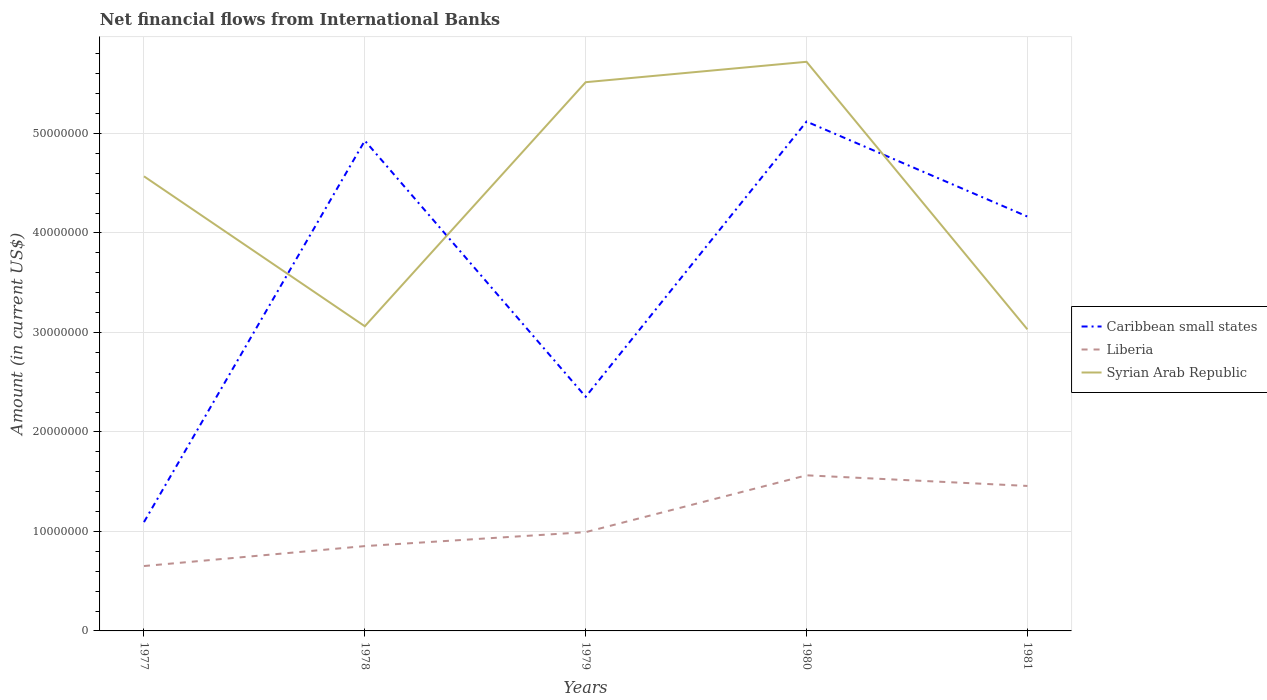How many different coloured lines are there?
Give a very brief answer. 3. Does the line corresponding to Caribbean small states intersect with the line corresponding to Syrian Arab Republic?
Your answer should be compact. Yes. Is the number of lines equal to the number of legend labels?
Your answer should be very brief. Yes. Across all years, what is the maximum net financial aid flows in Syrian Arab Republic?
Provide a succinct answer. 3.03e+07. What is the total net financial aid flows in Caribbean small states in the graph?
Your response must be concise. -1.81e+07. What is the difference between the highest and the second highest net financial aid flows in Liberia?
Provide a succinct answer. 9.12e+06. How many years are there in the graph?
Keep it short and to the point. 5. Are the values on the major ticks of Y-axis written in scientific E-notation?
Give a very brief answer. No. Does the graph contain any zero values?
Keep it short and to the point. No. Does the graph contain grids?
Your answer should be compact. Yes. What is the title of the graph?
Offer a very short reply. Net financial flows from International Banks. Does "Aruba" appear as one of the legend labels in the graph?
Make the answer very short. No. What is the label or title of the X-axis?
Your answer should be very brief. Years. What is the Amount (in current US$) in Caribbean small states in 1977?
Provide a succinct answer. 1.09e+07. What is the Amount (in current US$) of Liberia in 1977?
Give a very brief answer. 6.52e+06. What is the Amount (in current US$) in Syrian Arab Republic in 1977?
Keep it short and to the point. 4.57e+07. What is the Amount (in current US$) in Caribbean small states in 1978?
Your response must be concise. 4.93e+07. What is the Amount (in current US$) of Liberia in 1978?
Your answer should be very brief. 8.53e+06. What is the Amount (in current US$) of Syrian Arab Republic in 1978?
Your answer should be compact. 3.06e+07. What is the Amount (in current US$) of Caribbean small states in 1979?
Make the answer very short. 2.35e+07. What is the Amount (in current US$) in Liberia in 1979?
Provide a succinct answer. 9.93e+06. What is the Amount (in current US$) in Syrian Arab Republic in 1979?
Provide a short and direct response. 5.52e+07. What is the Amount (in current US$) in Caribbean small states in 1980?
Make the answer very short. 5.12e+07. What is the Amount (in current US$) of Liberia in 1980?
Provide a short and direct response. 1.56e+07. What is the Amount (in current US$) in Syrian Arab Republic in 1980?
Offer a very short reply. 5.72e+07. What is the Amount (in current US$) in Caribbean small states in 1981?
Your response must be concise. 4.16e+07. What is the Amount (in current US$) in Liberia in 1981?
Give a very brief answer. 1.46e+07. What is the Amount (in current US$) in Syrian Arab Republic in 1981?
Provide a short and direct response. 3.03e+07. Across all years, what is the maximum Amount (in current US$) in Caribbean small states?
Offer a very short reply. 5.12e+07. Across all years, what is the maximum Amount (in current US$) of Liberia?
Provide a short and direct response. 1.56e+07. Across all years, what is the maximum Amount (in current US$) in Syrian Arab Republic?
Make the answer very short. 5.72e+07. Across all years, what is the minimum Amount (in current US$) of Caribbean small states?
Your answer should be compact. 1.09e+07. Across all years, what is the minimum Amount (in current US$) of Liberia?
Offer a very short reply. 6.52e+06. Across all years, what is the minimum Amount (in current US$) in Syrian Arab Republic?
Ensure brevity in your answer.  3.03e+07. What is the total Amount (in current US$) in Caribbean small states in the graph?
Make the answer very short. 1.77e+08. What is the total Amount (in current US$) of Liberia in the graph?
Give a very brief answer. 5.52e+07. What is the total Amount (in current US$) of Syrian Arab Republic in the graph?
Provide a succinct answer. 2.19e+08. What is the difference between the Amount (in current US$) of Caribbean small states in 1977 and that in 1978?
Your answer should be compact. -3.83e+07. What is the difference between the Amount (in current US$) in Liberia in 1977 and that in 1978?
Offer a very short reply. -2.00e+06. What is the difference between the Amount (in current US$) in Syrian Arab Republic in 1977 and that in 1978?
Keep it short and to the point. 1.51e+07. What is the difference between the Amount (in current US$) in Caribbean small states in 1977 and that in 1979?
Keep it short and to the point. -1.26e+07. What is the difference between the Amount (in current US$) of Liberia in 1977 and that in 1979?
Make the answer very short. -3.41e+06. What is the difference between the Amount (in current US$) in Syrian Arab Republic in 1977 and that in 1979?
Offer a terse response. -9.46e+06. What is the difference between the Amount (in current US$) of Caribbean small states in 1977 and that in 1980?
Offer a very short reply. -4.03e+07. What is the difference between the Amount (in current US$) in Liberia in 1977 and that in 1980?
Give a very brief answer. -9.12e+06. What is the difference between the Amount (in current US$) of Syrian Arab Republic in 1977 and that in 1980?
Keep it short and to the point. -1.15e+07. What is the difference between the Amount (in current US$) in Caribbean small states in 1977 and that in 1981?
Offer a terse response. -3.07e+07. What is the difference between the Amount (in current US$) of Liberia in 1977 and that in 1981?
Make the answer very short. -8.05e+06. What is the difference between the Amount (in current US$) in Syrian Arab Republic in 1977 and that in 1981?
Offer a terse response. 1.54e+07. What is the difference between the Amount (in current US$) of Caribbean small states in 1978 and that in 1979?
Ensure brevity in your answer.  2.57e+07. What is the difference between the Amount (in current US$) of Liberia in 1978 and that in 1979?
Provide a short and direct response. -1.40e+06. What is the difference between the Amount (in current US$) of Syrian Arab Republic in 1978 and that in 1979?
Your answer should be very brief. -2.45e+07. What is the difference between the Amount (in current US$) in Caribbean small states in 1978 and that in 1980?
Keep it short and to the point. -1.92e+06. What is the difference between the Amount (in current US$) of Liberia in 1978 and that in 1980?
Your answer should be very brief. -7.11e+06. What is the difference between the Amount (in current US$) of Syrian Arab Republic in 1978 and that in 1980?
Offer a very short reply. -2.66e+07. What is the difference between the Amount (in current US$) of Caribbean small states in 1978 and that in 1981?
Give a very brief answer. 7.63e+06. What is the difference between the Amount (in current US$) of Liberia in 1978 and that in 1981?
Provide a succinct answer. -6.05e+06. What is the difference between the Amount (in current US$) in Syrian Arab Republic in 1978 and that in 1981?
Offer a very short reply. 3.11e+05. What is the difference between the Amount (in current US$) of Caribbean small states in 1979 and that in 1980?
Your answer should be very brief. -2.77e+07. What is the difference between the Amount (in current US$) of Liberia in 1979 and that in 1980?
Your answer should be very brief. -5.71e+06. What is the difference between the Amount (in current US$) of Syrian Arab Republic in 1979 and that in 1980?
Your answer should be very brief. -2.05e+06. What is the difference between the Amount (in current US$) in Caribbean small states in 1979 and that in 1981?
Your answer should be very brief. -1.81e+07. What is the difference between the Amount (in current US$) in Liberia in 1979 and that in 1981?
Offer a terse response. -4.64e+06. What is the difference between the Amount (in current US$) of Syrian Arab Republic in 1979 and that in 1981?
Ensure brevity in your answer.  2.48e+07. What is the difference between the Amount (in current US$) of Caribbean small states in 1980 and that in 1981?
Your answer should be very brief. 9.55e+06. What is the difference between the Amount (in current US$) of Liberia in 1980 and that in 1981?
Make the answer very short. 1.07e+06. What is the difference between the Amount (in current US$) in Syrian Arab Republic in 1980 and that in 1981?
Provide a succinct answer. 2.69e+07. What is the difference between the Amount (in current US$) in Caribbean small states in 1977 and the Amount (in current US$) in Liberia in 1978?
Ensure brevity in your answer.  2.41e+06. What is the difference between the Amount (in current US$) in Caribbean small states in 1977 and the Amount (in current US$) in Syrian Arab Republic in 1978?
Keep it short and to the point. -1.97e+07. What is the difference between the Amount (in current US$) in Liberia in 1977 and the Amount (in current US$) in Syrian Arab Republic in 1978?
Your answer should be very brief. -2.41e+07. What is the difference between the Amount (in current US$) of Caribbean small states in 1977 and the Amount (in current US$) of Liberia in 1979?
Provide a succinct answer. 1.01e+06. What is the difference between the Amount (in current US$) of Caribbean small states in 1977 and the Amount (in current US$) of Syrian Arab Republic in 1979?
Offer a very short reply. -4.42e+07. What is the difference between the Amount (in current US$) of Liberia in 1977 and the Amount (in current US$) of Syrian Arab Republic in 1979?
Offer a terse response. -4.86e+07. What is the difference between the Amount (in current US$) in Caribbean small states in 1977 and the Amount (in current US$) in Liberia in 1980?
Your response must be concise. -4.70e+06. What is the difference between the Amount (in current US$) in Caribbean small states in 1977 and the Amount (in current US$) in Syrian Arab Republic in 1980?
Your response must be concise. -4.63e+07. What is the difference between the Amount (in current US$) in Liberia in 1977 and the Amount (in current US$) in Syrian Arab Republic in 1980?
Offer a very short reply. -5.07e+07. What is the difference between the Amount (in current US$) in Caribbean small states in 1977 and the Amount (in current US$) in Liberia in 1981?
Give a very brief answer. -3.63e+06. What is the difference between the Amount (in current US$) in Caribbean small states in 1977 and the Amount (in current US$) in Syrian Arab Republic in 1981?
Keep it short and to the point. -1.94e+07. What is the difference between the Amount (in current US$) of Liberia in 1977 and the Amount (in current US$) of Syrian Arab Republic in 1981?
Ensure brevity in your answer.  -2.38e+07. What is the difference between the Amount (in current US$) in Caribbean small states in 1978 and the Amount (in current US$) in Liberia in 1979?
Your answer should be compact. 3.93e+07. What is the difference between the Amount (in current US$) of Caribbean small states in 1978 and the Amount (in current US$) of Syrian Arab Republic in 1979?
Give a very brief answer. -5.88e+06. What is the difference between the Amount (in current US$) in Liberia in 1978 and the Amount (in current US$) in Syrian Arab Republic in 1979?
Make the answer very short. -4.66e+07. What is the difference between the Amount (in current US$) of Caribbean small states in 1978 and the Amount (in current US$) of Liberia in 1980?
Ensure brevity in your answer.  3.36e+07. What is the difference between the Amount (in current US$) in Caribbean small states in 1978 and the Amount (in current US$) in Syrian Arab Republic in 1980?
Your answer should be very brief. -7.93e+06. What is the difference between the Amount (in current US$) in Liberia in 1978 and the Amount (in current US$) in Syrian Arab Republic in 1980?
Offer a terse response. -4.87e+07. What is the difference between the Amount (in current US$) of Caribbean small states in 1978 and the Amount (in current US$) of Liberia in 1981?
Provide a succinct answer. 3.47e+07. What is the difference between the Amount (in current US$) of Caribbean small states in 1978 and the Amount (in current US$) of Syrian Arab Republic in 1981?
Provide a short and direct response. 1.90e+07. What is the difference between the Amount (in current US$) in Liberia in 1978 and the Amount (in current US$) in Syrian Arab Republic in 1981?
Your answer should be very brief. -2.18e+07. What is the difference between the Amount (in current US$) in Caribbean small states in 1979 and the Amount (in current US$) in Liberia in 1980?
Keep it short and to the point. 7.90e+06. What is the difference between the Amount (in current US$) in Caribbean small states in 1979 and the Amount (in current US$) in Syrian Arab Republic in 1980?
Ensure brevity in your answer.  -3.37e+07. What is the difference between the Amount (in current US$) in Liberia in 1979 and the Amount (in current US$) in Syrian Arab Republic in 1980?
Your answer should be compact. -4.73e+07. What is the difference between the Amount (in current US$) of Caribbean small states in 1979 and the Amount (in current US$) of Liberia in 1981?
Provide a succinct answer. 8.96e+06. What is the difference between the Amount (in current US$) of Caribbean small states in 1979 and the Amount (in current US$) of Syrian Arab Republic in 1981?
Offer a terse response. -6.78e+06. What is the difference between the Amount (in current US$) of Liberia in 1979 and the Amount (in current US$) of Syrian Arab Republic in 1981?
Offer a very short reply. -2.04e+07. What is the difference between the Amount (in current US$) of Caribbean small states in 1980 and the Amount (in current US$) of Liberia in 1981?
Provide a short and direct response. 3.66e+07. What is the difference between the Amount (in current US$) of Caribbean small states in 1980 and the Amount (in current US$) of Syrian Arab Republic in 1981?
Give a very brief answer. 2.09e+07. What is the difference between the Amount (in current US$) in Liberia in 1980 and the Amount (in current US$) in Syrian Arab Republic in 1981?
Make the answer very short. -1.47e+07. What is the average Amount (in current US$) of Caribbean small states per year?
Provide a short and direct response. 3.53e+07. What is the average Amount (in current US$) in Liberia per year?
Your response must be concise. 1.10e+07. What is the average Amount (in current US$) in Syrian Arab Republic per year?
Offer a terse response. 4.38e+07. In the year 1977, what is the difference between the Amount (in current US$) of Caribbean small states and Amount (in current US$) of Liberia?
Keep it short and to the point. 4.42e+06. In the year 1977, what is the difference between the Amount (in current US$) in Caribbean small states and Amount (in current US$) in Syrian Arab Republic?
Your response must be concise. -3.48e+07. In the year 1977, what is the difference between the Amount (in current US$) of Liberia and Amount (in current US$) of Syrian Arab Republic?
Your response must be concise. -3.92e+07. In the year 1978, what is the difference between the Amount (in current US$) in Caribbean small states and Amount (in current US$) in Liberia?
Offer a terse response. 4.08e+07. In the year 1978, what is the difference between the Amount (in current US$) in Caribbean small states and Amount (in current US$) in Syrian Arab Republic?
Ensure brevity in your answer.  1.87e+07. In the year 1978, what is the difference between the Amount (in current US$) in Liberia and Amount (in current US$) in Syrian Arab Republic?
Offer a very short reply. -2.21e+07. In the year 1979, what is the difference between the Amount (in current US$) of Caribbean small states and Amount (in current US$) of Liberia?
Make the answer very short. 1.36e+07. In the year 1979, what is the difference between the Amount (in current US$) of Caribbean small states and Amount (in current US$) of Syrian Arab Republic?
Provide a short and direct response. -3.16e+07. In the year 1979, what is the difference between the Amount (in current US$) in Liberia and Amount (in current US$) in Syrian Arab Republic?
Make the answer very short. -4.52e+07. In the year 1980, what is the difference between the Amount (in current US$) in Caribbean small states and Amount (in current US$) in Liberia?
Ensure brevity in your answer.  3.56e+07. In the year 1980, what is the difference between the Amount (in current US$) in Caribbean small states and Amount (in current US$) in Syrian Arab Republic?
Offer a very short reply. -6.01e+06. In the year 1980, what is the difference between the Amount (in current US$) in Liberia and Amount (in current US$) in Syrian Arab Republic?
Your answer should be very brief. -4.16e+07. In the year 1981, what is the difference between the Amount (in current US$) of Caribbean small states and Amount (in current US$) of Liberia?
Ensure brevity in your answer.  2.71e+07. In the year 1981, what is the difference between the Amount (in current US$) of Caribbean small states and Amount (in current US$) of Syrian Arab Republic?
Provide a succinct answer. 1.13e+07. In the year 1981, what is the difference between the Amount (in current US$) in Liberia and Amount (in current US$) in Syrian Arab Republic?
Your answer should be compact. -1.57e+07. What is the ratio of the Amount (in current US$) in Caribbean small states in 1977 to that in 1978?
Offer a terse response. 0.22. What is the ratio of the Amount (in current US$) of Liberia in 1977 to that in 1978?
Offer a very short reply. 0.77. What is the ratio of the Amount (in current US$) in Syrian Arab Republic in 1977 to that in 1978?
Provide a short and direct response. 1.49. What is the ratio of the Amount (in current US$) of Caribbean small states in 1977 to that in 1979?
Make the answer very short. 0.46. What is the ratio of the Amount (in current US$) of Liberia in 1977 to that in 1979?
Your response must be concise. 0.66. What is the ratio of the Amount (in current US$) of Syrian Arab Republic in 1977 to that in 1979?
Make the answer very short. 0.83. What is the ratio of the Amount (in current US$) of Caribbean small states in 1977 to that in 1980?
Give a very brief answer. 0.21. What is the ratio of the Amount (in current US$) of Liberia in 1977 to that in 1980?
Provide a succinct answer. 0.42. What is the ratio of the Amount (in current US$) of Syrian Arab Republic in 1977 to that in 1980?
Provide a succinct answer. 0.8. What is the ratio of the Amount (in current US$) of Caribbean small states in 1977 to that in 1981?
Make the answer very short. 0.26. What is the ratio of the Amount (in current US$) of Liberia in 1977 to that in 1981?
Make the answer very short. 0.45. What is the ratio of the Amount (in current US$) of Syrian Arab Republic in 1977 to that in 1981?
Offer a very short reply. 1.51. What is the ratio of the Amount (in current US$) in Caribbean small states in 1978 to that in 1979?
Keep it short and to the point. 2.09. What is the ratio of the Amount (in current US$) in Liberia in 1978 to that in 1979?
Provide a succinct answer. 0.86. What is the ratio of the Amount (in current US$) of Syrian Arab Republic in 1978 to that in 1979?
Offer a very short reply. 0.56. What is the ratio of the Amount (in current US$) of Caribbean small states in 1978 to that in 1980?
Keep it short and to the point. 0.96. What is the ratio of the Amount (in current US$) in Liberia in 1978 to that in 1980?
Your answer should be compact. 0.55. What is the ratio of the Amount (in current US$) of Syrian Arab Republic in 1978 to that in 1980?
Keep it short and to the point. 0.54. What is the ratio of the Amount (in current US$) in Caribbean small states in 1978 to that in 1981?
Offer a terse response. 1.18. What is the ratio of the Amount (in current US$) of Liberia in 1978 to that in 1981?
Give a very brief answer. 0.59. What is the ratio of the Amount (in current US$) of Syrian Arab Republic in 1978 to that in 1981?
Your answer should be very brief. 1.01. What is the ratio of the Amount (in current US$) of Caribbean small states in 1979 to that in 1980?
Offer a very short reply. 0.46. What is the ratio of the Amount (in current US$) in Liberia in 1979 to that in 1980?
Provide a short and direct response. 0.63. What is the ratio of the Amount (in current US$) in Syrian Arab Republic in 1979 to that in 1980?
Keep it short and to the point. 0.96. What is the ratio of the Amount (in current US$) of Caribbean small states in 1979 to that in 1981?
Make the answer very short. 0.57. What is the ratio of the Amount (in current US$) in Liberia in 1979 to that in 1981?
Provide a succinct answer. 0.68. What is the ratio of the Amount (in current US$) in Syrian Arab Republic in 1979 to that in 1981?
Give a very brief answer. 1.82. What is the ratio of the Amount (in current US$) in Caribbean small states in 1980 to that in 1981?
Your answer should be very brief. 1.23. What is the ratio of the Amount (in current US$) of Liberia in 1980 to that in 1981?
Ensure brevity in your answer.  1.07. What is the ratio of the Amount (in current US$) in Syrian Arab Republic in 1980 to that in 1981?
Provide a succinct answer. 1.89. What is the difference between the highest and the second highest Amount (in current US$) of Caribbean small states?
Your answer should be compact. 1.92e+06. What is the difference between the highest and the second highest Amount (in current US$) in Liberia?
Provide a short and direct response. 1.07e+06. What is the difference between the highest and the second highest Amount (in current US$) of Syrian Arab Republic?
Keep it short and to the point. 2.05e+06. What is the difference between the highest and the lowest Amount (in current US$) in Caribbean small states?
Offer a very short reply. 4.03e+07. What is the difference between the highest and the lowest Amount (in current US$) of Liberia?
Your answer should be compact. 9.12e+06. What is the difference between the highest and the lowest Amount (in current US$) in Syrian Arab Republic?
Provide a succinct answer. 2.69e+07. 